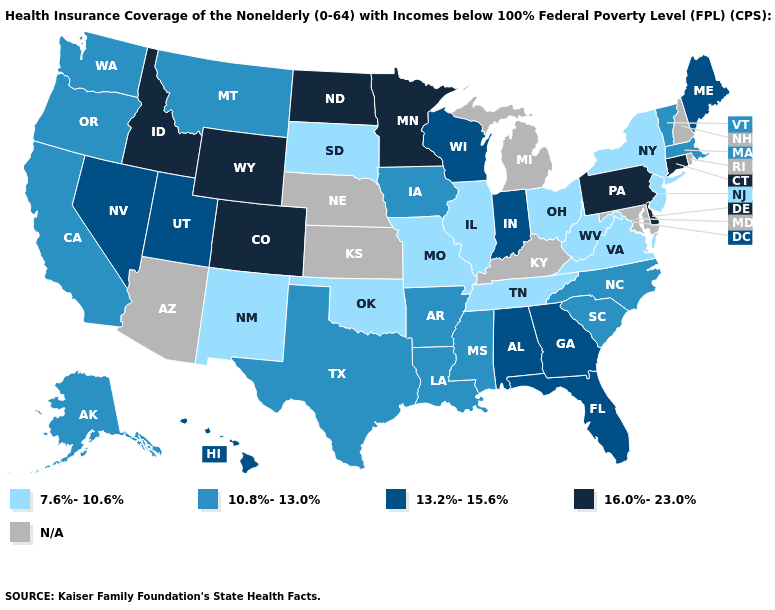Which states have the highest value in the USA?
Short answer required. Colorado, Connecticut, Delaware, Idaho, Minnesota, North Dakota, Pennsylvania, Wyoming. What is the value of Arkansas?
Answer briefly. 10.8%-13.0%. Which states hav the highest value in the South?
Quick response, please. Delaware. Name the states that have a value in the range N/A?
Write a very short answer. Arizona, Kansas, Kentucky, Maryland, Michigan, Nebraska, New Hampshire, Rhode Island. What is the highest value in states that border Nebraska?
Quick response, please. 16.0%-23.0%. What is the value of Colorado?
Keep it brief. 16.0%-23.0%. What is the value of Mississippi?
Keep it brief. 10.8%-13.0%. Does the first symbol in the legend represent the smallest category?
Write a very short answer. Yes. Name the states that have a value in the range N/A?
Quick response, please. Arizona, Kansas, Kentucky, Maryland, Michigan, Nebraska, New Hampshire, Rhode Island. Name the states that have a value in the range 16.0%-23.0%?
Give a very brief answer. Colorado, Connecticut, Delaware, Idaho, Minnesota, North Dakota, Pennsylvania, Wyoming. Among the states that border Minnesota , does North Dakota have the highest value?
Concise answer only. Yes. What is the lowest value in the USA?
Answer briefly. 7.6%-10.6%. What is the lowest value in the USA?
Keep it brief. 7.6%-10.6%. 